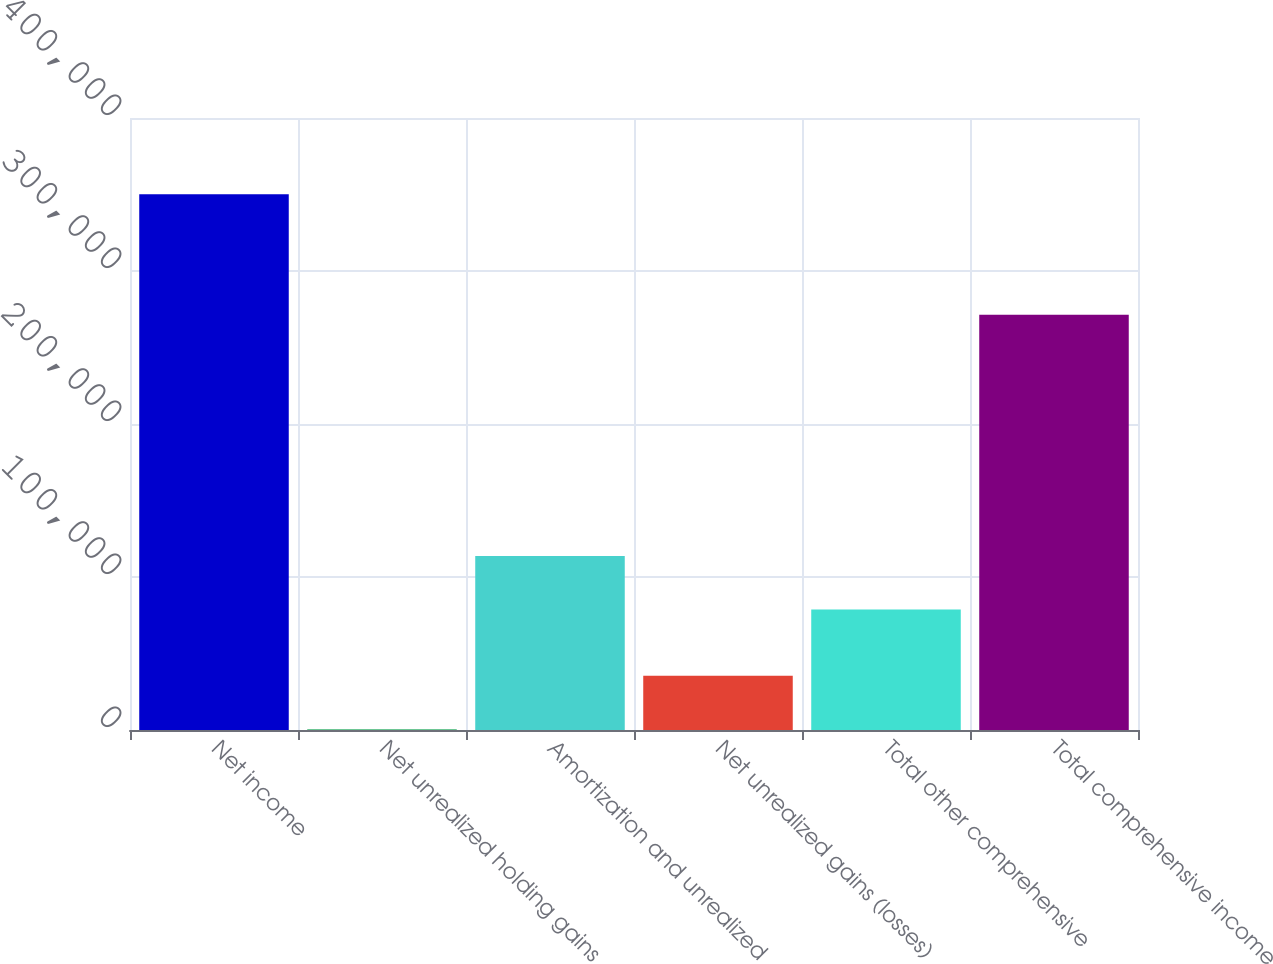Convert chart to OTSL. <chart><loc_0><loc_0><loc_500><loc_500><bar_chart><fcel>Net income<fcel>Net unrealized holding gains<fcel>Amortization and unrealized<fcel>Net unrealized gains (losses)<fcel>Total other comprehensive<fcel>Total comprehensive income<nl><fcel>350104<fcel>465<fcel>113656<fcel>35428.9<fcel>78692<fcel>271412<nl></chart> 